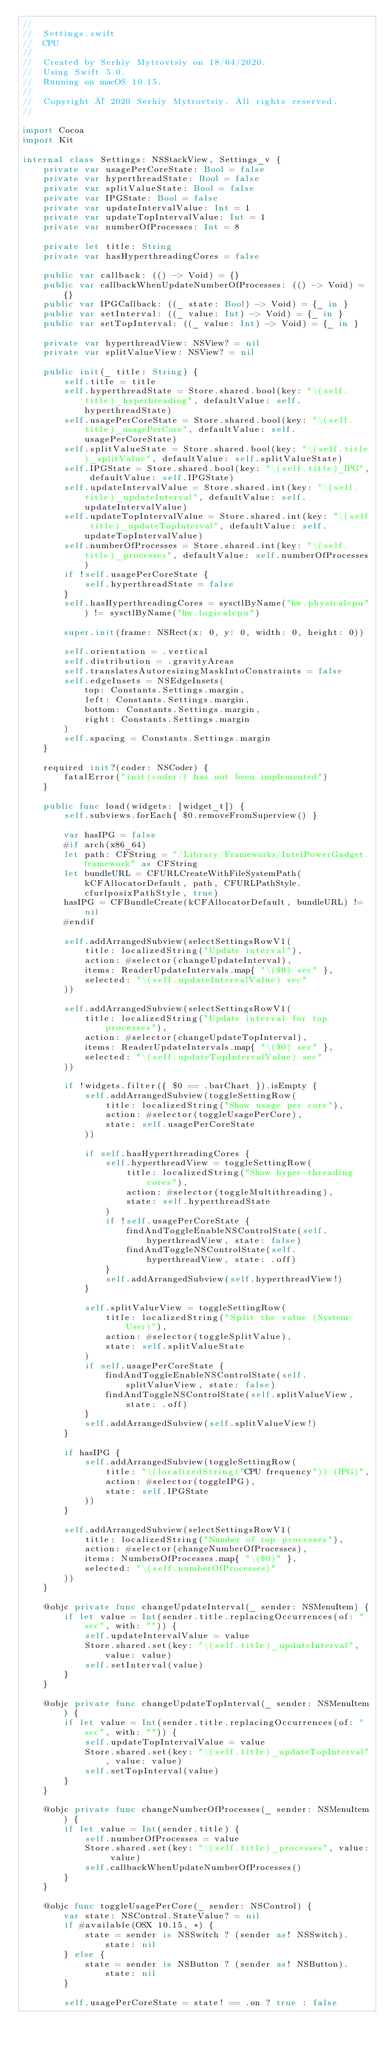Convert code to text. <code><loc_0><loc_0><loc_500><loc_500><_Swift_>//
//  Settings.swift
//  CPU
//
//  Created by Serhiy Mytrovtsiy on 18/04/2020.
//  Using Swift 5.0.
//  Running on macOS 10.15.
//
//  Copyright © 2020 Serhiy Mytrovtsiy. All rights reserved.
//

import Cocoa
import Kit

internal class Settings: NSStackView, Settings_v {
    private var usagePerCoreState: Bool = false
    private var hyperthreadState: Bool = false
    private var splitValueState: Bool = false
    private var IPGState: Bool = false
    private var updateIntervalValue: Int = 1
    private var updateTopIntervalValue: Int = 1
    private var numberOfProcesses: Int = 8
    
    private let title: String
    private var hasHyperthreadingCores = false
    
    public var callback: (() -> Void) = {}
    public var callbackWhenUpdateNumberOfProcesses: (() -> Void) = {}
    public var IPGCallback: ((_ state: Bool) -> Void) = {_ in }
    public var setInterval: ((_ value: Int) -> Void) = {_ in }
    public var setTopInterval: ((_ value: Int) -> Void) = {_ in }
    
    private var hyperthreadView: NSView? = nil
    private var splitValueView: NSView? = nil
    
    public init(_ title: String) {
        self.title = title
        self.hyperthreadState = Store.shared.bool(key: "\(self.title)_hyperhreading", defaultValue: self.hyperthreadState)
        self.usagePerCoreState = Store.shared.bool(key: "\(self.title)_usagePerCore", defaultValue: self.usagePerCoreState)
        self.splitValueState = Store.shared.bool(key: "\(self.title)_splitValue", defaultValue: self.splitValueState)
        self.IPGState = Store.shared.bool(key: "\(self.title)_IPG", defaultValue: self.IPGState)
        self.updateIntervalValue = Store.shared.int(key: "\(self.title)_updateInterval", defaultValue: self.updateIntervalValue)
        self.updateTopIntervalValue = Store.shared.int(key: "\(self.title)_updateTopInterval", defaultValue: self.updateTopIntervalValue)
        self.numberOfProcesses = Store.shared.int(key: "\(self.title)_processes", defaultValue: self.numberOfProcesses)
        if !self.usagePerCoreState {
            self.hyperthreadState = false
        }
        self.hasHyperthreadingCores = sysctlByName("hw.physicalcpu") != sysctlByName("hw.logicalcpu")
        
        super.init(frame: NSRect(x: 0, y: 0, width: 0, height: 0))
        
        self.orientation = .vertical
        self.distribution = .gravityAreas
        self.translatesAutoresizingMaskIntoConstraints = false
        self.edgeInsets = NSEdgeInsets(
            top: Constants.Settings.margin,
            left: Constants.Settings.margin,
            bottom: Constants.Settings.margin,
            right: Constants.Settings.margin
        )
        self.spacing = Constants.Settings.margin
    }
    
    required init?(coder: NSCoder) {
        fatalError("init(coder:) has not been implemented")
    }
    
    public func load(widgets: [widget_t]) {
        self.subviews.forEach{ $0.removeFromSuperview() }
        
        var hasIPG = false
        #if arch(x86_64)
        let path: CFString = "/Library/Frameworks/IntelPowerGadget.framework" as CFString
        let bundleURL = CFURLCreateWithFileSystemPath(kCFAllocatorDefault, path, CFURLPathStyle.cfurlposixPathStyle, true)
        hasIPG = CFBundleCreate(kCFAllocatorDefault, bundleURL) != nil
        #endif
        
        self.addArrangedSubview(selectSettingsRowV1(
            title: localizedString("Update interval"),
            action: #selector(changeUpdateInterval),
            items: ReaderUpdateIntervals.map{ "\($0) sec" },
            selected: "\(self.updateIntervalValue) sec"
        ))
        
        self.addArrangedSubview(selectSettingsRowV1(
            title: localizedString("Update interval for top processes"),
            action: #selector(changeUpdateTopInterval),
            items: ReaderUpdateIntervals.map{ "\($0) sec" },
            selected: "\(self.updateTopIntervalValue) sec"
        ))
        
        if !widgets.filter({ $0 == .barChart }).isEmpty {
            self.addArrangedSubview(toggleSettingRow(
                title: localizedString("Show usage per core"),
                action: #selector(toggleUsagePerCore),
                state: self.usagePerCoreState
            ))
            
            if self.hasHyperthreadingCores {
                self.hyperthreadView = toggleSettingRow(
                    title: localizedString("Show hyper-threading cores"),
                    action: #selector(toggleMultithreading),
                    state: self.hyperthreadState
                )
                if !self.usagePerCoreState {
                    findAndToggleEnableNSControlState(self.hyperthreadView, state: false)
                    findAndToggleNSControlState(self.hyperthreadView, state: .off)
                }
                self.addArrangedSubview(self.hyperthreadView!)
            }
            
            self.splitValueView = toggleSettingRow(
                title: localizedString("Split the value (System/User)"),
                action: #selector(toggleSplitValue),
                state: self.splitValueState
            )
            if self.usagePerCoreState {
                findAndToggleEnableNSControlState(self.splitValueView, state: false)
                findAndToggleNSControlState(self.splitValueView, state: .off)
            }
            self.addArrangedSubview(self.splitValueView!)
        }
        
        if hasIPG {
            self.addArrangedSubview(toggleSettingRow(
                title: "\(localizedString("CPU frequency")) (IPG)",
                action: #selector(toggleIPG),
                state: self.IPGState
            ))
        }
        
        self.addArrangedSubview(selectSettingsRowV1(
            title: localizedString("Number of top processes"),
            action: #selector(changeNumberOfProcesses),
            items: NumbersOfProcesses.map{ "\($0)" },
            selected: "\(self.numberOfProcesses)"
        ))
    }
    
    @objc private func changeUpdateInterval(_ sender: NSMenuItem) {
        if let value = Int(sender.title.replacingOccurrences(of: " sec", with: "")) {
            self.updateIntervalValue = value
            Store.shared.set(key: "\(self.title)_updateInterval", value: value)
            self.setInterval(value)
        }
    }
    
    @objc private func changeUpdateTopInterval(_ sender: NSMenuItem) {
        if let value = Int(sender.title.replacingOccurrences(of: " sec", with: "")) {
            self.updateTopIntervalValue = value
            Store.shared.set(key: "\(self.title)_updateTopInterval", value: value)
            self.setTopInterval(value)
        }
    }
    
    @objc private func changeNumberOfProcesses(_ sender: NSMenuItem) {
        if let value = Int(sender.title) {
            self.numberOfProcesses = value
            Store.shared.set(key: "\(self.title)_processes", value: value)
            self.callbackWhenUpdateNumberOfProcesses()
        }
    }
    
    @objc func toggleUsagePerCore(_ sender: NSControl) {
        var state: NSControl.StateValue? = nil
        if #available(OSX 10.15, *) {
            state = sender is NSSwitch ? (sender as! NSSwitch).state: nil
        } else {
            state = sender is NSButton ? (sender as! NSButton).state: nil
        }
        
        self.usagePerCoreState = state! == .on ? true : false</code> 